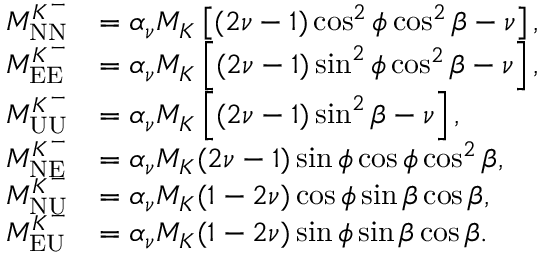Convert formula to latex. <formula><loc_0><loc_0><loc_500><loc_500>\begin{array} { r l } { M _ { N N } ^ { K ^ { - } } } & { = \alpha _ { \nu } M _ { K } \left [ ( 2 \nu - 1 ) \cos ^ { 2 } \phi \cos ^ { 2 } \beta - \nu \right ] , } \\ { M _ { E E } ^ { K ^ { - } } } & { = \alpha _ { \nu } M _ { K } \left [ ( 2 \nu - 1 ) \sin ^ { 2 } \phi \cos ^ { 2 } \beta - \nu \right ] , } \\ { M _ { U U } ^ { K ^ { - } } } & { = \alpha _ { \nu } M _ { K } \left [ ( 2 \nu - 1 ) \sin ^ { 2 } \beta - \nu \right ] , } \\ { M _ { N E } ^ { K ^ { - } } } & { = \alpha _ { \nu } M _ { K } ( 2 \nu - 1 ) \sin \phi \cos \phi \cos ^ { 2 } \beta , } \\ { M _ { N U } ^ { K ^ { - } } } & { = \alpha _ { \nu } M _ { K } ( 1 - 2 \nu ) \cos \phi \sin \beta \cos \beta , } \\ { M _ { E U } ^ { K ^ { - } } } & { = \alpha _ { \nu } M _ { K } ( 1 - 2 \nu ) \sin \phi \sin \beta \cos \beta . } \end{array}</formula> 